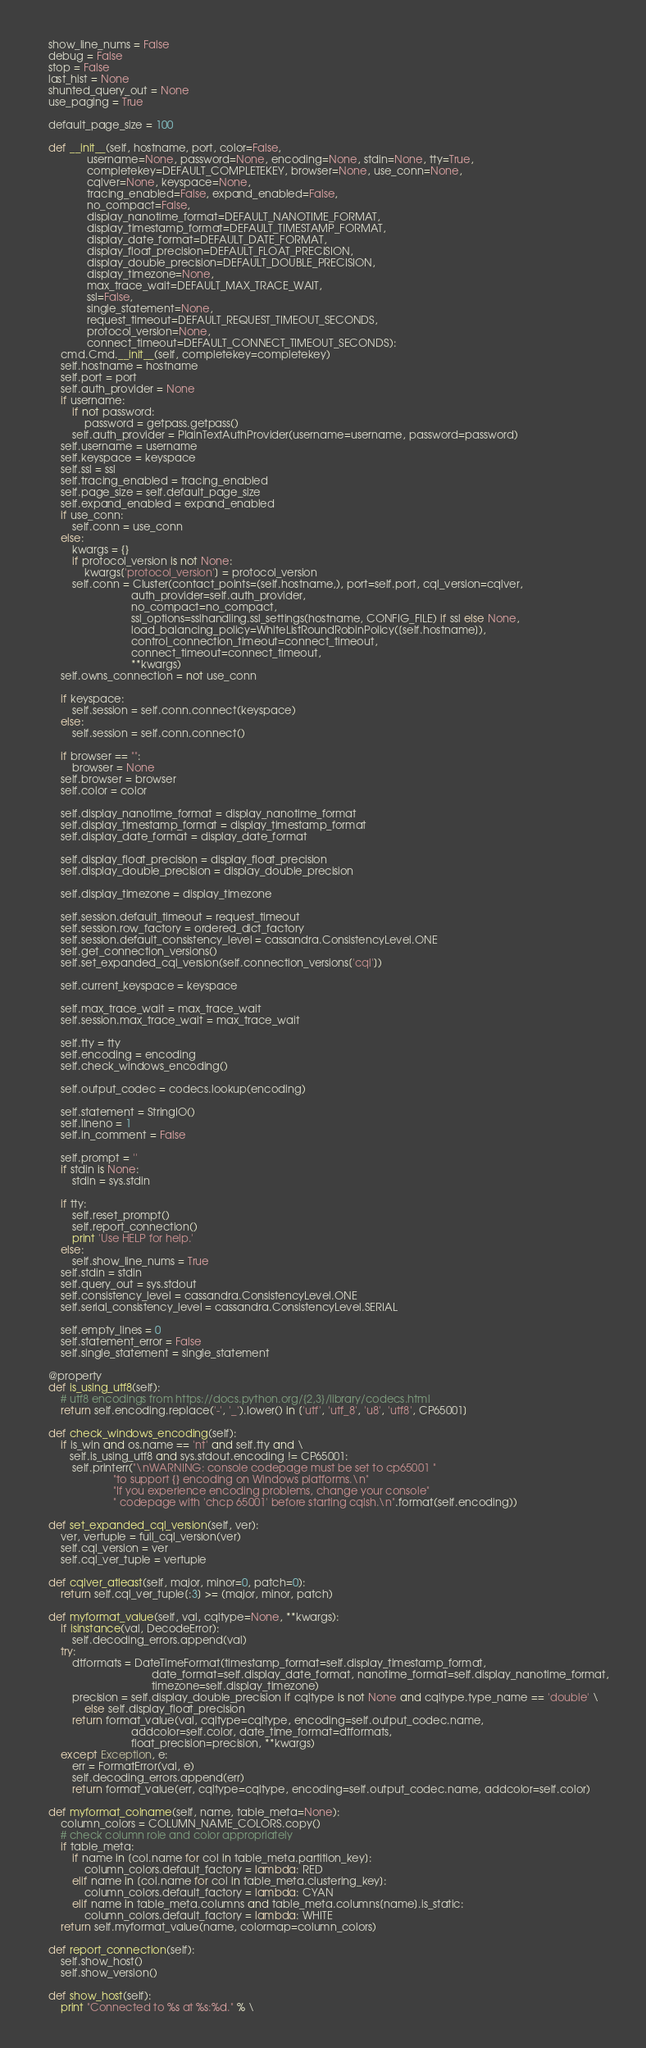<code> <loc_0><loc_0><loc_500><loc_500><_Python_>    show_line_nums = False
    debug = False
    stop = False
    last_hist = None
    shunted_query_out = None
    use_paging = True

    default_page_size = 100

    def __init__(self, hostname, port, color=False,
                 username=None, password=None, encoding=None, stdin=None, tty=True,
                 completekey=DEFAULT_COMPLETEKEY, browser=None, use_conn=None,
                 cqlver=None, keyspace=None,
                 tracing_enabled=False, expand_enabled=False,
                 no_compact=False,
                 display_nanotime_format=DEFAULT_NANOTIME_FORMAT,
                 display_timestamp_format=DEFAULT_TIMESTAMP_FORMAT,
                 display_date_format=DEFAULT_DATE_FORMAT,
                 display_float_precision=DEFAULT_FLOAT_PRECISION,
                 display_double_precision=DEFAULT_DOUBLE_PRECISION,
                 display_timezone=None,
                 max_trace_wait=DEFAULT_MAX_TRACE_WAIT,
                 ssl=False,
                 single_statement=None,
                 request_timeout=DEFAULT_REQUEST_TIMEOUT_SECONDS,
                 protocol_version=None,
                 connect_timeout=DEFAULT_CONNECT_TIMEOUT_SECONDS):
        cmd.Cmd.__init__(self, completekey=completekey)
        self.hostname = hostname
        self.port = port
        self.auth_provider = None
        if username:
            if not password:
                password = getpass.getpass()
            self.auth_provider = PlainTextAuthProvider(username=username, password=password)
        self.username = username
        self.keyspace = keyspace
        self.ssl = ssl
        self.tracing_enabled = tracing_enabled
        self.page_size = self.default_page_size
        self.expand_enabled = expand_enabled
        if use_conn:
            self.conn = use_conn
        else:
            kwargs = {}
            if protocol_version is not None:
                kwargs['protocol_version'] = protocol_version
            self.conn = Cluster(contact_points=(self.hostname,), port=self.port, cql_version=cqlver,
                                auth_provider=self.auth_provider,
                                no_compact=no_compact,
                                ssl_options=sslhandling.ssl_settings(hostname, CONFIG_FILE) if ssl else None,
                                load_balancing_policy=WhiteListRoundRobinPolicy([self.hostname]),
                                control_connection_timeout=connect_timeout,
                                connect_timeout=connect_timeout,
                                **kwargs)
        self.owns_connection = not use_conn

        if keyspace:
            self.session = self.conn.connect(keyspace)
        else:
            self.session = self.conn.connect()

        if browser == "":
            browser = None
        self.browser = browser
        self.color = color

        self.display_nanotime_format = display_nanotime_format
        self.display_timestamp_format = display_timestamp_format
        self.display_date_format = display_date_format

        self.display_float_precision = display_float_precision
        self.display_double_precision = display_double_precision

        self.display_timezone = display_timezone

        self.session.default_timeout = request_timeout
        self.session.row_factory = ordered_dict_factory
        self.session.default_consistency_level = cassandra.ConsistencyLevel.ONE
        self.get_connection_versions()
        self.set_expanded_cql_version(self.connection_versions['cql'])

        self.current_keyspace = keyspace

        self.max_trace_wait = max_trace_wait
        self.session.max_trace_wait = max_trace_wait

        self.tty = tty
        self.encoding = encoding
        self.check_windows_encoding()

        self.output_codec = codecs.lookup(encoding)

        self.statement = StringIO()
        self.lineno = 1
        self.in_comment = False

        self.prompt = ''
        if stdin is None:
            stdin = sys.stdin

        if tty:
            self.reset_prompt()
            self.report_connection()
            print 'Use HELP for help.'
        else:
            self.show_line_nums = True
        self.stdin = stdin
        self.query_out = sys.stdout
        self.consistency_level = cassandra.ConsistencyLevel.ONE
        self.serial_consistency_level = cassandra.ConsistencyLevel.SERIAL

        self.empty_lines = 0
        self.statement_error = False
        self.single_statement = single_statement

    @property
    def is_using_utf8(self):
        # utf8 encodings from https://docs.python.org/{2,3}/library/codecs.html
        return self.encoding.replace('-', '_').lower() in ['utf', 'utf_8', 'u8', 'utf8', CP65001]

    def check_windows_encoding(self):
        if is_win and os.name == 'nt' and self.tty and \
           self.is_using_utf8 and sys.stdout.encoding != CP65001:
            self.printerr("\nWARNING: console codepage must be set to cp65001 "
                          "to support {} encoding on Windows platforms.\n"
                          "If you experience encoding problems, change your console"
                          " codepage with 'chcp 65001' before starting cqlsh.\n".format(self.encoding))

    def set_expanded_cql_version(self, ver):
        ver, vertuple = full_cql_version(ver)
        self.cql_version = ver
        self.cql_ver_tuple = vertuple

    def cqlver_atleast(self, major, minor=0, patch=0):
        return self.cql_ver_tuple[:3] >= (major, minor, patch)

    def myformat_value(self, val, cqltype=None, **kwargs):
        if isinstance(val, DecodeError):
            self.decoding_errors.append(val)
        try:
            dtformats = DateTimeFormat(timestamp_format=self.display_timestamp_format,
                                       date_format=self.display_date_format, nanotime_format=self.display_nanotime_format,
                                       timezone=self.display_timezone)
            precision = self.display_double_precision if cqltype is not None and cqltype.type_name == 'double' \
                else self.display_float_precision
            return format_value(val, cqltype=cqltype, encoding=self.output_codec.name,
                                addcolor=self.color, date_time_format=dtformats,
                                float_precision=precision, **kwargs)
        except Exception, e:
            err = FormatError(val, e)
            self.decoding_errors.append(err)
            return format_value(err, cqltype=cqltype, encoding=self.output_codec.name, addcolor=self.color)

    def myformat_colname(self, name, table_meta=None):
        column_colors = COLUMN_NAME_COLORS.copy()
        # check column role and color appropriately
        if table_meta:
            if name in [col.name for col in table_meta.partition_key]:
                column_colors.default_factory = lambda: RED
            elif name in [col.name for col in table_meta.clustering_key]:
                column_colors.default_factory = lambda: CYAN
            elif name in table_meta.columns and table_meta.columns[name].is_static:
                column_colors.default_factory = lambda: WHITE
        return self.myformat_value(name, colormap=column_colors)

    def report_connection(self):
        self.show_host()
        self.show_version()

    def show_host(self):
        print "Connected to %s at %s:%d." % \</code> 